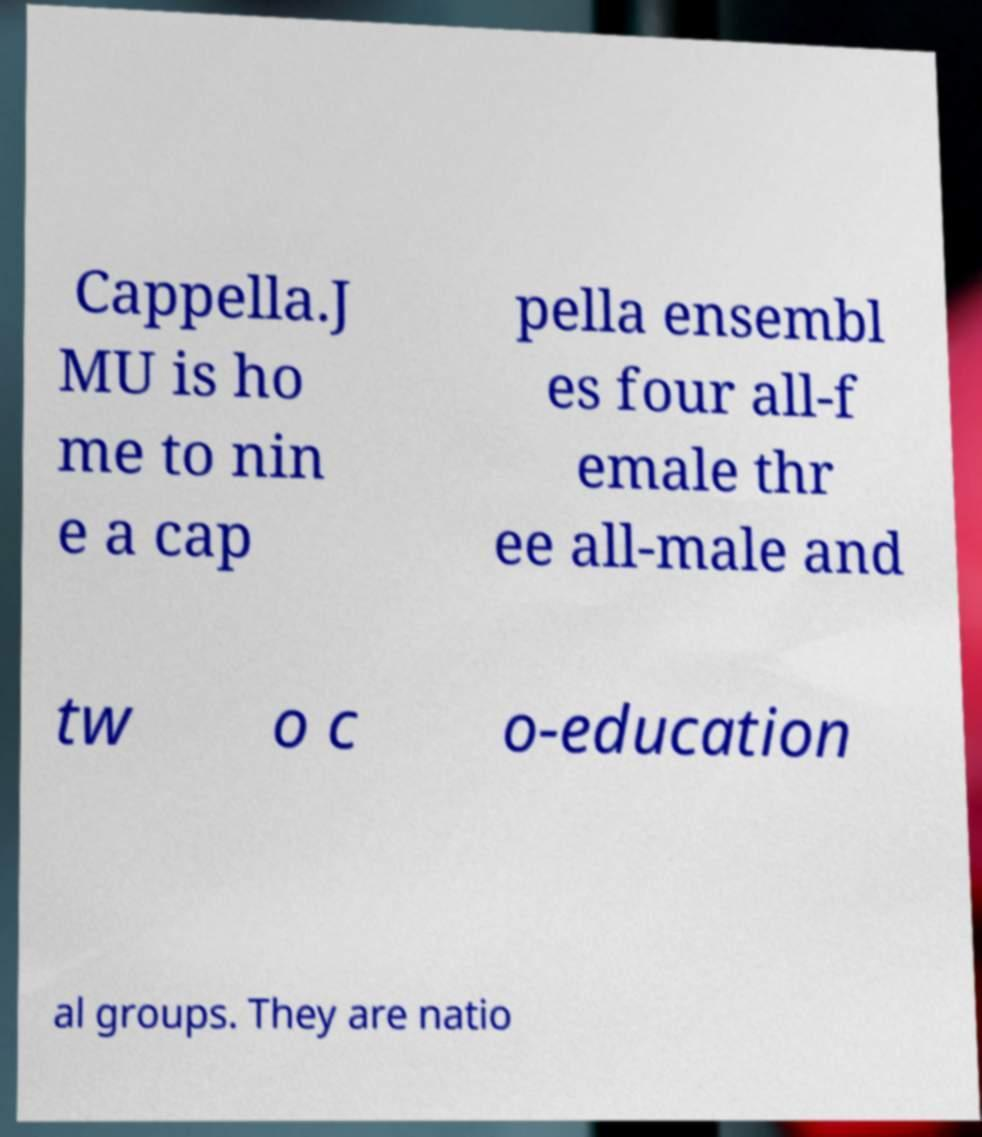What messages or text are displayed in this image? I need them in a readable, typed format. Cappella.J MU is ho me to nin e a cap pella ensembl es four all-f emale thr ee all-male and tw o c o-education al groups. They are natio 